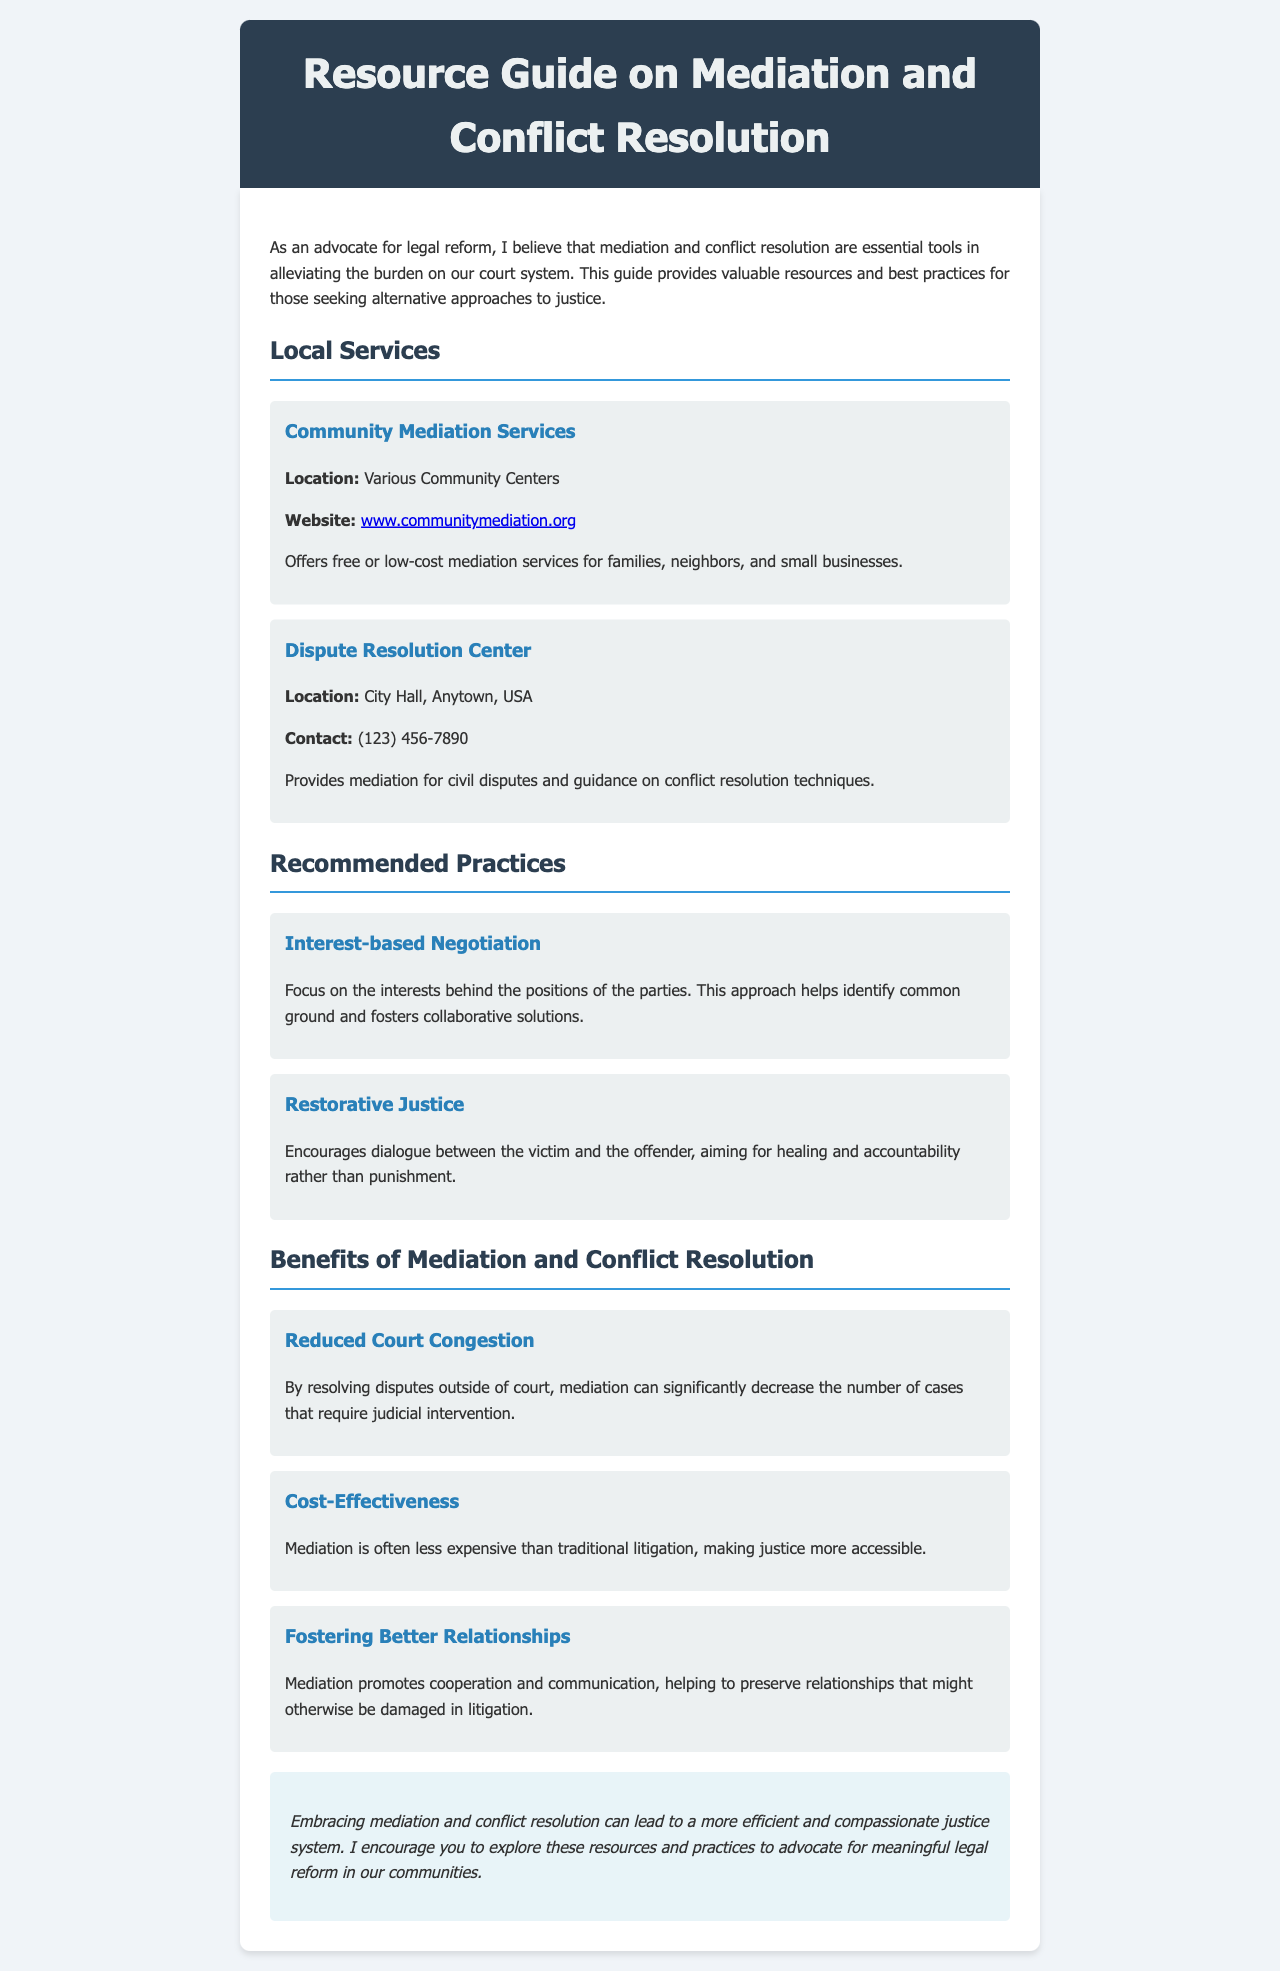What is the title of the document? The title of the document is provided in the header section.
Answer: Resource Guide on Mediation and Conflict Resolution Where is the Dispute Resolution Center located? The location of the Dispute Resolution Center is listed in the local services section.
Answer: City Hall, Anytown, USA What is one recommended practice mentioned in the document? The document lists several recommended practices under a specific section.
Answer: Interest-based Negotiation What benefit does mediation provide related to court cases? The benefits section highlights various advantages of mediation regarding court cases.
Answer: Reduced Court Congestion What is the website for Community Mediation Services? The website is listed under the community mediation services section.
Answer: www.communitymediation.org Why might mediation be considered cost-effective? The document explains cost-effectiveness in the benefits section related to litigation.
Answer: Less expensive than traditional litigation What is the overall aim of restorative justice? The document describes the aim of restorative justice in the recommended practices section.
Answer: Healing and accountability What style is used for the text in the document? The font style is specified in the CSS for the document's body.
Answer: Segoe UI, Tahoma, Geneva, Verdana, sans-serif Who is the intended audience for the Resource Guide? The introduction indicates the audience is targeted for legal reform advocates.
Answer: Advocates for legal reform 